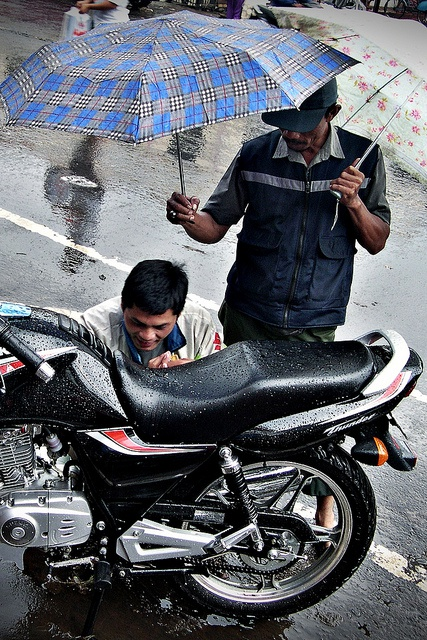Describe the objects in this image and their specific colors. I can see motorcycle in black, gray, lightgray, and darkgray tones, people in black, gray, navy, and maroon tones, umbrella in black, darkgray, lightblue, and gray tones, umbrella in black, lightgray, darkgray, and gray tones, and people in black, lightgray, darkgray, and gray tones in this image. 